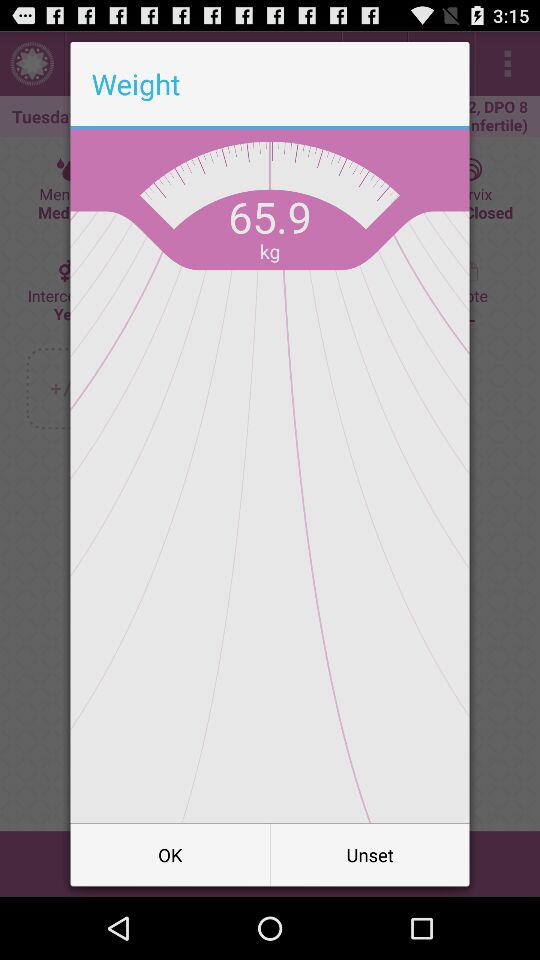What is the unit of weight? The unit of weight is kilograms. 